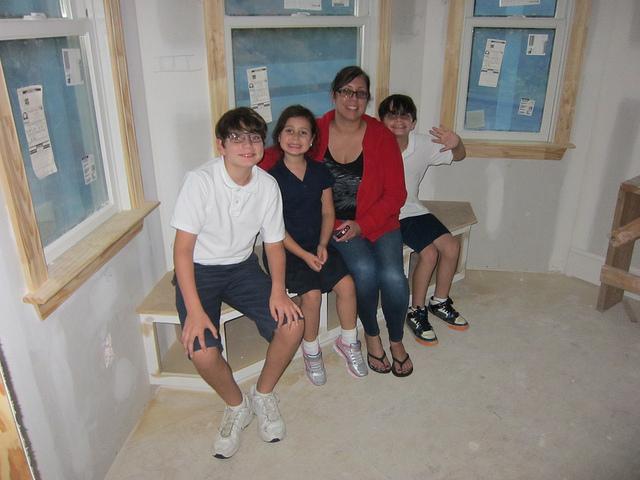Are they looking at the camera?
Be succinct. Yes. Do the people look happy?
Keep it brief. Yes. Are they playing a game?
Give a very brief answer. No. What is this person doing?
Answer briefly. Sitting. Are the curtains open of closed?
Give a very brief answer. Open. Is the floor made of tile or linoleum?
Concise answer only. Linoleum. Whom is wearing slippers?
Give a very brief answer. Woman. What color is the girls hair?
Write a very short answer. Black. Is this house new or old?
Give a very brief answer. New. 